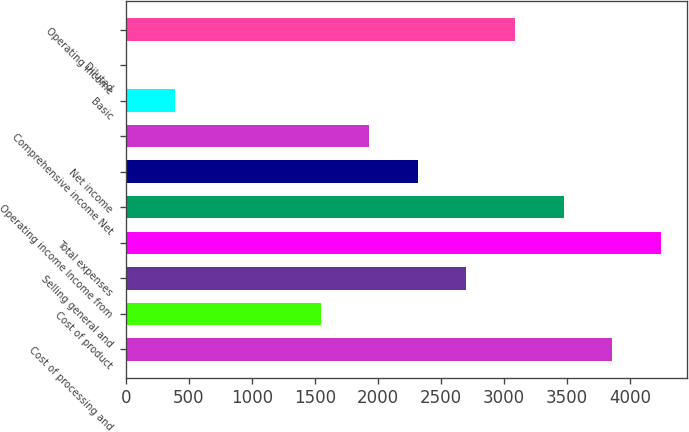<chart> <loc_0><loc_0><loc_500><loc_500><bar_chart><fcel>Cost of processing and<fcel>Cost of product<fcel>Selling general and<fcel>Total expenses<fcel>Operating income Income from<fcel>Net income<fcel>Comprehensive income Net<fcel>Basic<fcel>Diluted<fcel>Operating income<nl><fcel>3855.99<fcel>1544.19<fcel>2700.09<fcel>4241.29<fcel>3470.69<fcel>2314.79<fcel>1929.49<fcel>388.29<fcel>2.99<fcel>3085.39<nl></chart> 